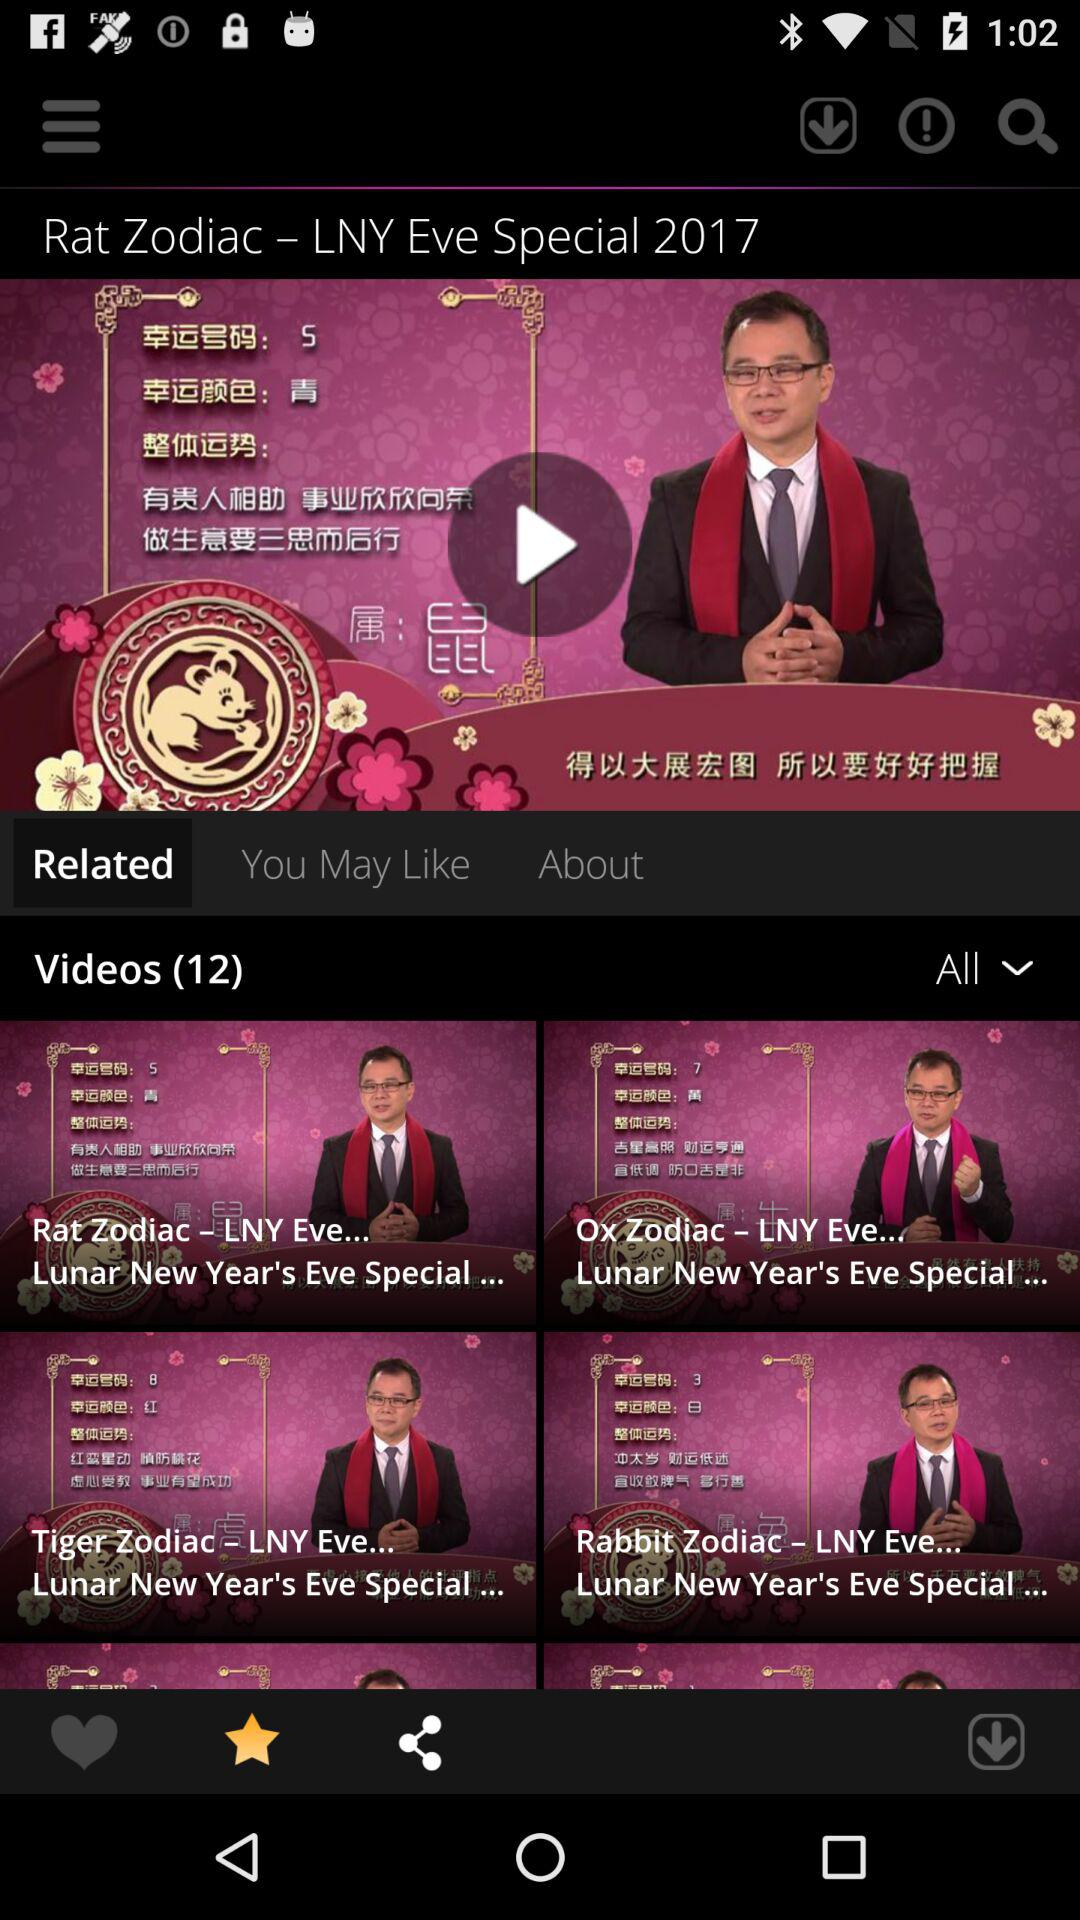How many videos are there? There are 12 videos. 